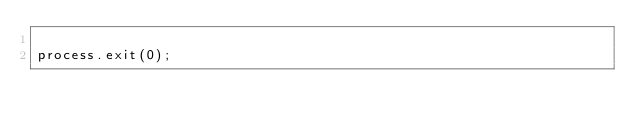<code> <loc_0><loc_0><loc_500><loc_500><_JavaScript_>
process.exit(0);
</code> 